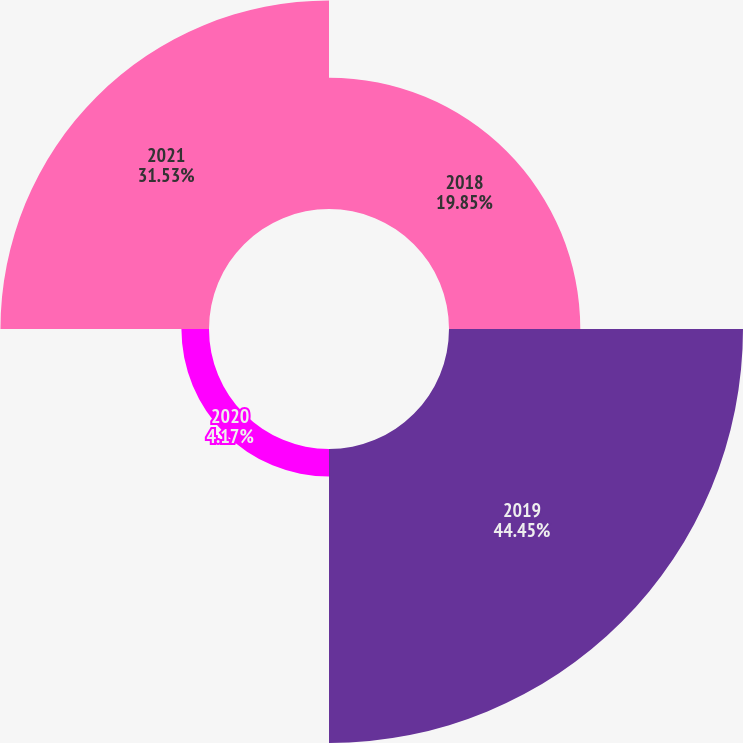Convert chart to OTSL. <chart><loc_0><loc_0><loc_500><loc_500><pie_chart><fcel>2018<fcel>2019<fcel>2020<fcel>2021<nl><fcel>19.85%<fcel>44.45%<fcel>4.17%<fcel>31.53%<nl></chart> 